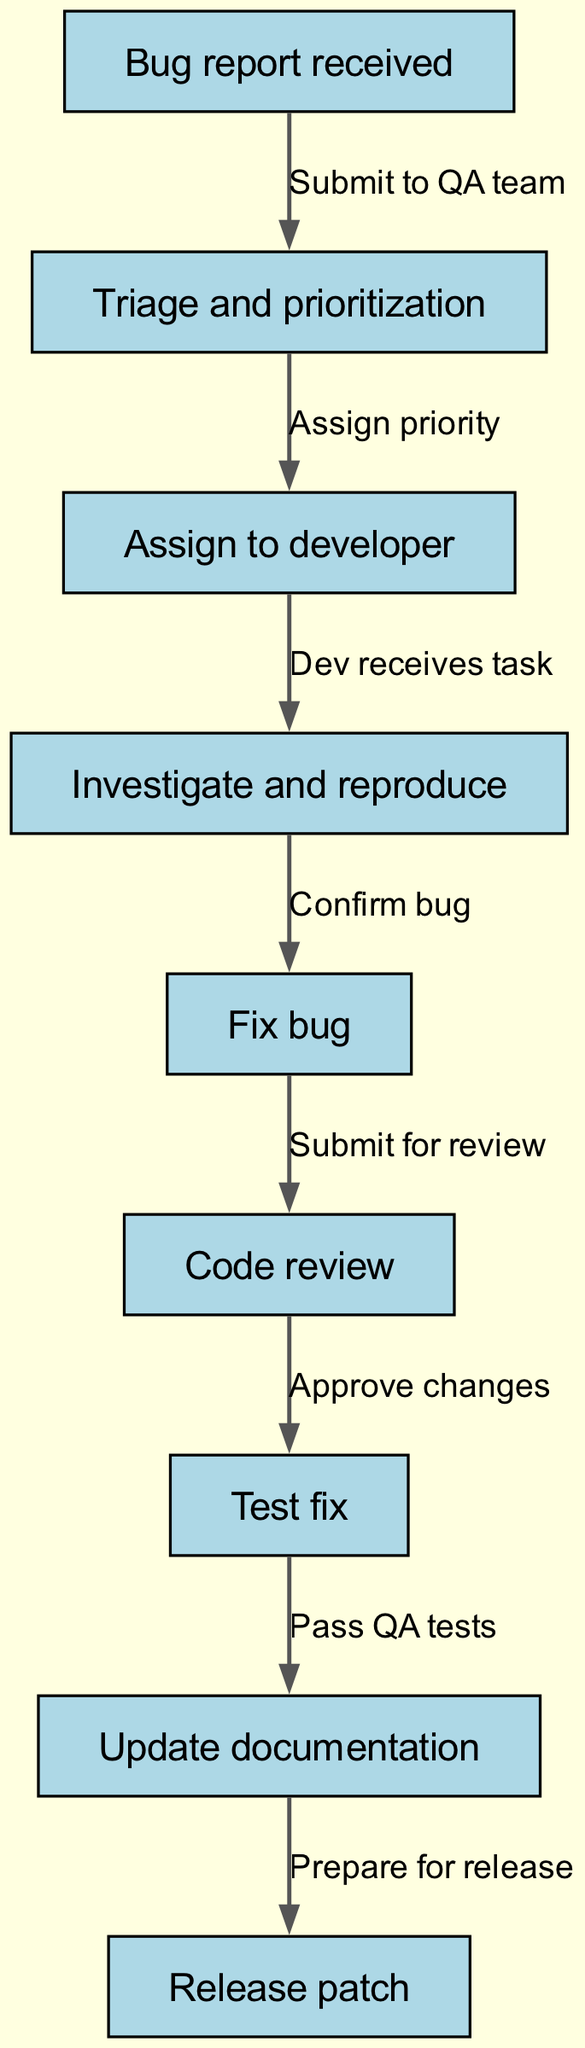What is the first step in the workflow? The first node in the diagram is labeled "Bug report received," which indicates that this is the starting point of the workflow.
Answer: Bug report received How many total nodes are present in the diagram? By counting all the nodes listed in the data, I identified that there are 9 nodes in total, as indicated by the number of entries under "nodes."
Answer: 9 What is the last step that occurs in the workflow? The last node in the diagram is labeled "Release patch," which signifies the final action taken at the end of this workflow process.
Answer: Release patch What action is performed after "Test fix"? The directed edge connected from "Test fix" to "Update documentation" indicates that this is the next action to be completed following testing.
Answer: Update documentation How many edges are in the diagram? I counted the edges listed in the data, totaling 8 connections, which represent the relationships and transitions between the nodes.
Answer: 8 Which node follows "Assign to developer"? The diagram shows that the node "Investigate and reproduce" directly follows "Assign to developer," indicating the next step in the process after assignment.
Answer: Investigate and reproduce What does the edge from "Fix bug" to "Code review" indicate? This edge signifies that after the bug is fixed, it is then submitted for a code review as the next step before further actions can take place.
Answer: Submit for review What is the relationship between "Triage and prioritization" and "Assign to developer"? The edge connecting these nodes specifies "Assign priority," which highlights the decision-making involved in prioritizing the bug report before it is assigned.
Answer: Assign priority What action happens directly after "Pass QA tests"? The edge leading from "Pass QA tests" to "Update documentation" shows that updating documentation is the subsequent action following the successful testing of the fix.
Answer: Update documentation 